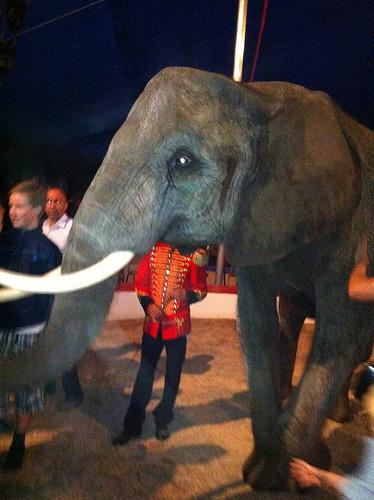Question: how many elephants are shown?
Choices:
A. Two.
B. Three.
C. Four.
D. One.
Answer with the letter. Answer: D Question: where are the people?
Choices:
A. Near cheetah.
B. Around elephant.
C. In the field.
D. On the hill.
Answer with the letter. Answer: B Question: where is the ring?
Choices:
A. Outside sand.
B. On sidewalk.
C. On side of house.
D. On car.
Answer with the letter. Answer: A Question: what color are the tusks?
Choices:
A. White.
B. Ivory.
C. Silver.
D. Grey.
Answer with the letter. Answer: A Question: where is the elephant?
Choices:
A. In sand.
B. In a field.
C. Behind the trees.
D. On the grass.
Answer with the letter. Answer: A 